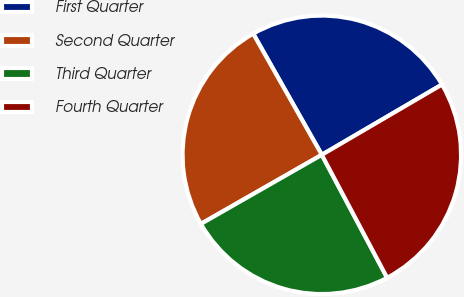<chart> <loc_0><loc_0><loc_500><loc_500><pie_chart><fcel>First Quarter<fcel>Second Quarter<fcel>Third Quarter<fcel>Fourth Quarter<nl><fcel>24.78%<fcel>25.06%<fcel>24.51%<fcel>25.65%<nl></chart> 